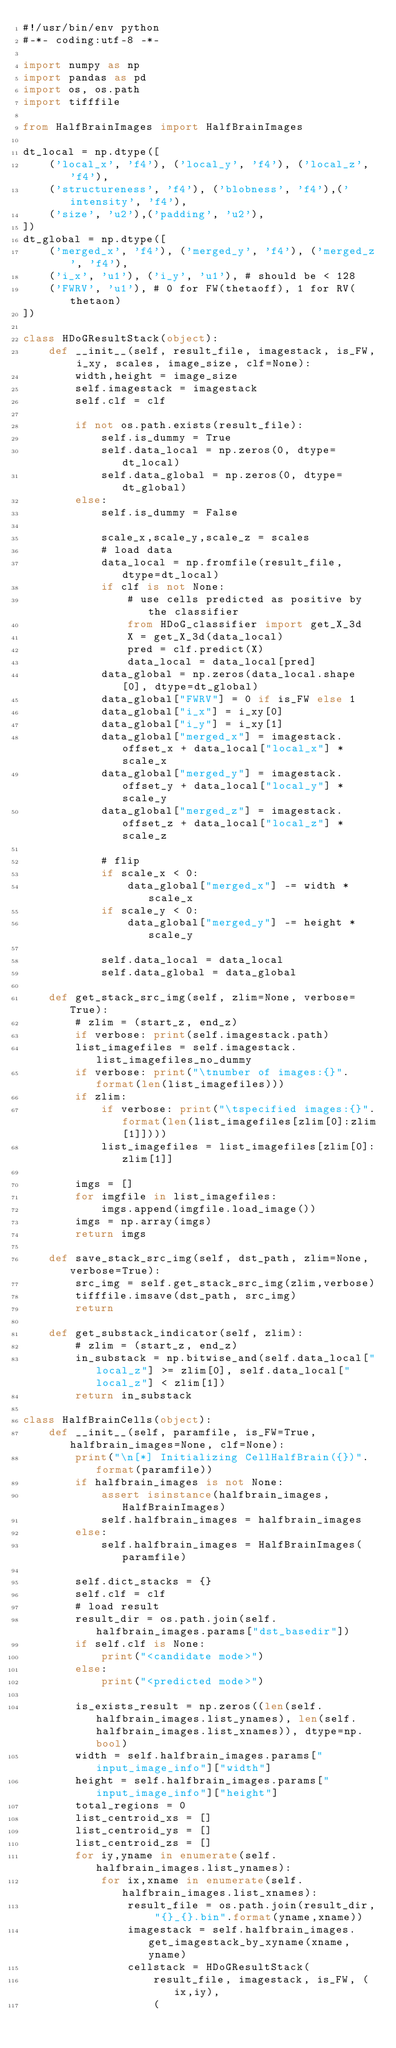<code> <loc_0><loc_0><loc_500><loc_500><_Python_>#!/usr/bin/env python
#-*- coding:utf-8 -*-

import numpy as np
import pandas as pd
import os, os.path
import tifffile

from HalfBrainImages import HalfBrainImages

dt_local = np.dtype([
    ('local_x', 'f4'), ('local_y', 'f4'), ('local_z', 'f4'),
    ('structureness', 'f4'), ('blobness', 'f4'),('intensity', 'f4'),
    ('size', 'u2'),('padding', 'u2'),
])
dt_global = np.dtype([
    ('merged_x', 'f4'), ('merged_y', 'f4'), ('merged_z', 'f4'),
    ('i_x', 'u1'), ('i_y', 'u1'), # should be < 128
    ('FWRV', 'u1'), # 0 for FW(thetaoff), 1 for RV(thetaon)
])

class HDoGResultStack(object):
    def __init__(self, result_file, imagestack, is_FW, i_xy, scales, image_size, clf=None):
        width,height = image_size
        self.imagestack = imagestack
        self.clf = clf

        if not os.path.exists(result_file):
            self.is_dummy = True
            self.data_local = np.zeros(0, dtype=dt_local)
            self.data_global = np.zeros(0, dtype=dt_global)
        else:
            self.is_dummy = False

            scale_x,scale_y,scale_z = scales
            # load data
            data_local = np.fromfile(result_file, dtype=dt_local)
            if clf is not None:
                # use cells predicted as positive by the classifier
                from HDoG_classifier import get_X_3d
                X = get_X_3d(data_local)
                pred = clf.predict(X)
                data_local = data_local[pred]
            data_global = np.zeros(data_local.shape[0], dtype=dt_global)
            data_global["FWRV"] = 0 if is_FW else 1
            data_global["i_x"] = i_xy[0]
            data_global["i_y"] = i_xy[1]
            data_global["merged_x"] = imagestack.offset_x + data_local["local_x"] * scale_x
            data_global["merged_y"] = imagestack.offset_y + data_local["local_y"] * scale_y
            data_global["merged_z"] = imagestack.offset_z + data_local["local_z"] * scale_z

            # flip
            if scale_x < 0:
                data_global["merged_x"] -= width * scale_x
            if scale_y < 0:
                data_global["merged_y"] -= height * scale_y

            self.data_local = data_local
            self.data_global = data_global

    def get_stack_src_img(self, zlim=None, verbose=True):
        # zlim = (start_z, end_z)
        if verbose: print(self.imagestack.path)
        list_imagefiles = self.imagestack.list_imagefiles_no_dummy
        if verbose: print("\tnumber of images:{}".format(len(list_imagefiles)))
        if zlim:
            if verbose: print("\tspecified images:{}".format(len(list_imagefiles[zlim[0]:zlim[1]])))
            list_imagefiles = list_imagefiles[zlim[0]:zlim[1]]

        imgs = []
        for imgfile in list_imagefiles:
            imgs.append(imgfile.load_image())
        imgs = np.array(imgs)
        return imgs

    def save_stack_src_img(self, dst_path, zlim=None, verbose=True):
        src_img = self.get_stack_src_img(zlim,verbose)
        tifffile.imsave(dst_path, src_img)
        return

    def get_substack_indicator(self, zlim):
        # zlim = (start_z, end_z)
        in_substack = np.bitwise_and(self.data_local["local_z"] >= zlim[0], self.data_local["local_z"] < zlim[1])
        return in_substack

class HalfBrainCells(object):
    def __init__(self, paramfile, is_FW=True, halfbrain_images=None, clf=None):
        print("\n[*] Initializing CellHalfBrain({})".format(paramfile))
        if halfbrain_images is not None:
            assert isinstance(halfbrain_images, HalfBrainImages)
            self.halfbrain_images = halfbrain_images
        else:
            self.halfbrain_images = HalfBrainImages(paramfile)

        self.dict_stacks = {}
        self.clf = clf
        # load result
        result_dir = os.path.join(self.halfbrain_images.params["dst_basedir"])
        if self.clf is None:
            print("<candidate mode>")
        else:
            print("<predicted mode>")

        is_exists_result = np.zeros((len(self.halfbrain_images.list_ynames), len(self.halfbrain_images.list_xnames)), dtype=np.bool)
        width = self.halfbrain_images.params["input_image_info"]["width"]
        height = self.halfbrain_images.params["input_image_info"]["height"]
        total_regions = 0
        list_centroid_xs = []
        list_centroid_ys = []
        list_centroid_zs = []
        for iy,yname in enumerate(self.halfbrain_images.list_ynames):
            for ix,xname in enumerate(self.halfbrain_images.list_xnames):
                result_file = os.path.join(result_dir, "{}_{}.bin".format(yname,xname))
                imagestack = self.halfbrain_images.get_imagestack_by_xyname(xname,yname)
                cellstack = HDoGResultStack(
                    result_file, imagestack, is_FW, (ix,iy),
                    (</code> 